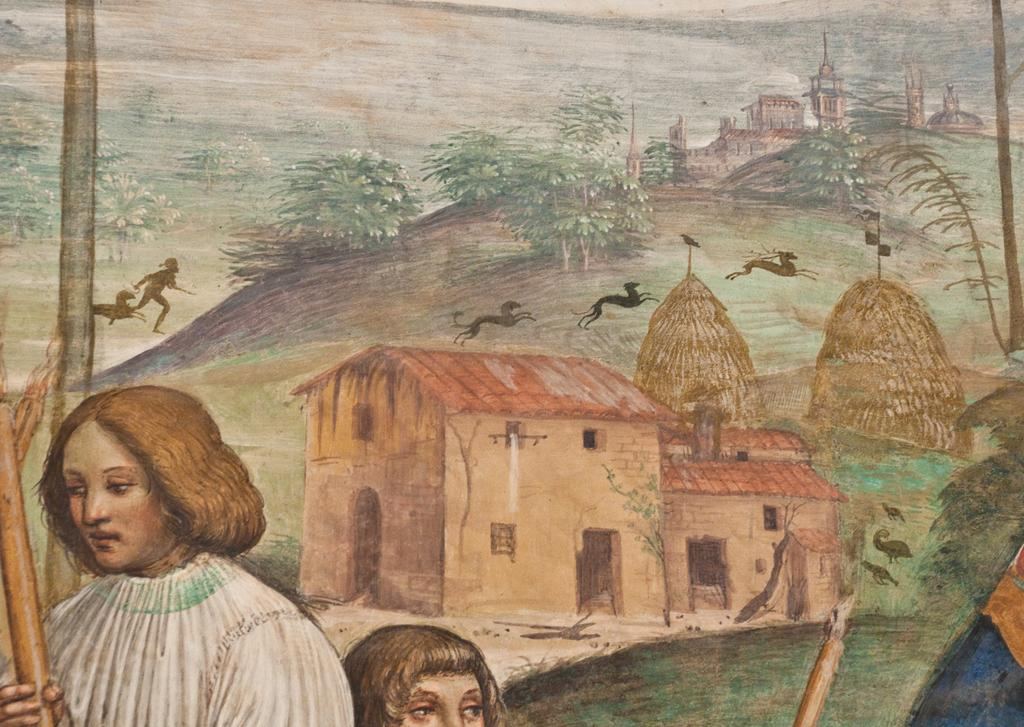What type of structures are depicted in the painting? The painting contains houses. What type of natural elements are depicted in the painting? The painting contains trees. What type of living beings are depicted in the painting? The painting contains animals and people. What is the level of wealth depicted in the painting? The level of wealth cannot be determined from the painting, as it does not contain any specific indicators of wealth. 